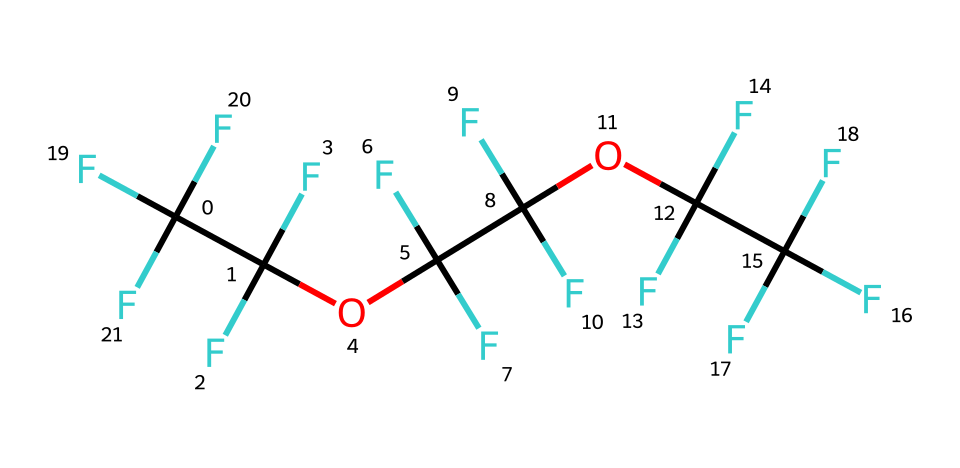What is the total number of carbon atoms in this structure? In the provided SMILES notation, we can identify each carbon (C) by counting the occurrences of 'C'. The structure shows three main carbon chains and peripheral ones, leading to a total of 9 carbon atoms.
Answer: 9 How many fluorine atoms are present in the chemical? In the SMILES representation, 'F' indicates fluorine atoms. By counting each occurrence of 'F', we can determine there are 18 fluorine atoms.
Answer: 18 What functional groups can be identified in this structure? The presence of 'OC' indicates the presence of ether functional groups in the structure. These function to decrease friction in lubricants.
Answer: ether Is this compound likely to be hydrophobic or hydrophilic? The high number of fluorine atoms and lack of polar groups suggest that this compound is hydrophobic, meaning it repels water.
Answer: hydrophobic What is the primary application of PFPE lubricants? PFPE lubricants are commonly used in computer hard drives due to their thermal stability and excellent lubricating properties.
Answer: computer hard drives Which properties make PFPE a suitable lubricant for high-performance applications? The chemical structure of PFPE provides excellent thermal stability, low volatility, and resistance to chemical attack, making it ideal for high-performance applications.
Answer: thermal stability 